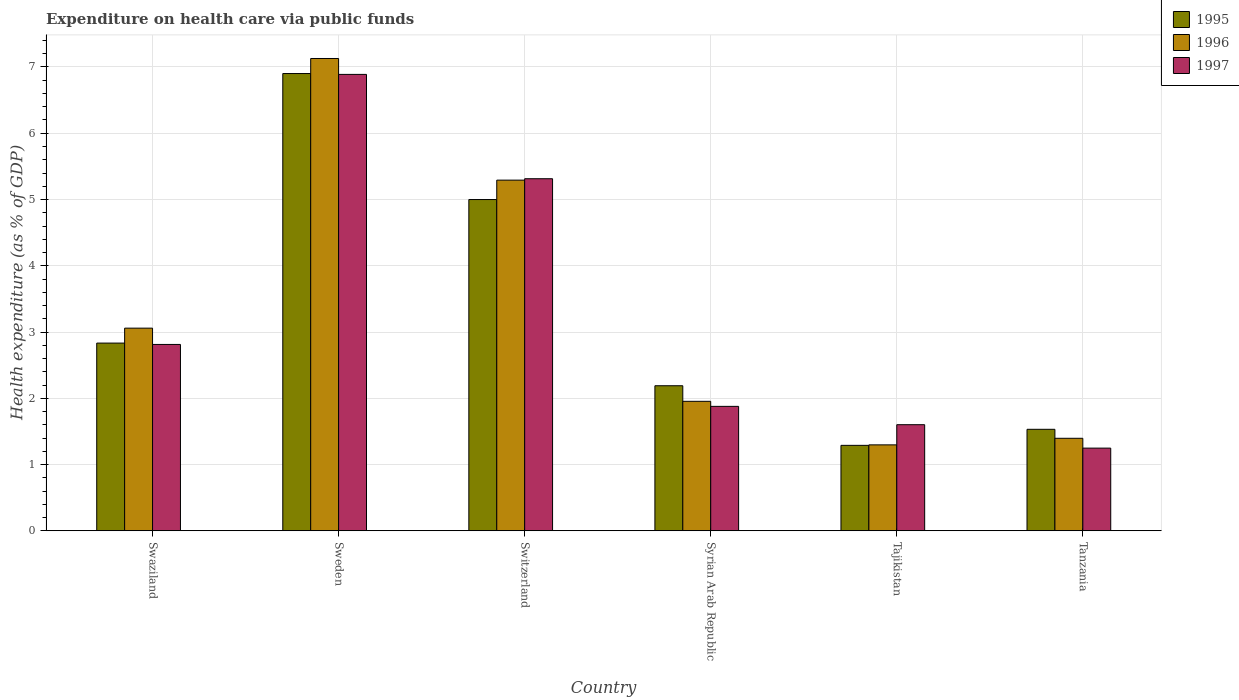How many different coloured bars are there?
Provide a succinct answer. 3. How many groups of bars are there?
Ensure brevity in your answer.  6. Are the number of bars per tick equal to the number of legend labels?
Keep it short and to the point. Yes. How many bars are there on the 2nd tick from the left?
Offer a very short reply. 3. How many bars are there on the 4th tick from the right?
Provide a short and direct response. 3. What is the label of the 6th group of bars from the left?
Your response must be concise. Tanzania. In how many cases, is the number of bars for a given country not equal to the number of legend labels?
Make the answer very short. 0. What is the expenditure made on health care in 1997 in Sweden?
Make the answer very short. 6.89. Across all countries, what is the maximum expenditure made on health care in 1995?
Your answer should be compact. 6.9. Across all countries, what is the minimum expenditure made on health care in 1996?
Your response must be concise. 1.3. In which country was the expenditure made on health care in 1996 maximum?
Your response must be concise. Sweden. In which country was the expenditure made on health care in 1995 minimum?
Provide a short and direct response. Tajikistan. What is the total expenditure made on health care in 1997 in the graph?
Ensure brevity in your answer.  19.74. What is the difference between the expenditure made on health care in 1995 in Sweden and that in Tajikistan?
Offer a terse response. 5.61. What is the difference between the expenditure made on health care in 1996 in Switzerland and the expenditure made on health care in 1997 in Sweden?
Provide a succinct answer. -1.6. What is the average expenditure made on health care in 1996 per country?
Make the answer very short. 3.35. What is the difference between the expenditure made on health care of/in 1996 and expenditure made on health care of/in 1997 in Swaziland?
Provide a succinct answer. 0.25. What is the ratio of the expenditure made on health care in 1997 in Tajikistan to that in Tanzania?
Your answer should be very brief. 1.28. Is the expenditure made on health care in 1996 in Switzerland less than that in Tajikistan?
Give a very brief answer. No. Is the difference between the expenditure made on health care in 1996 in Tajikistan and Tanzania greater than the difference between the expenditure made on health care in 1997 in Tajikistan and Tanzania?
Your answer should be compact. No. What is the difference between the highest and the second highest expenditure made on health care in 1997?
Provide a succinct answer. -2.5. What is the difference between the highest and the lowest expenditure made on health care in 1996?
Offer a terse response. 5.83. In how many countries, is the expenditure made on health care in 1997 greater than the average expenditure made on health care in 1997 taken over all countries?
Provide a succinct answer. 2. What does the 3rd bar from the left in Tajikistan represents?
Offer a very short reply. 1997. How many bars are there?
Your answer should be very brief. 18. Are all the bars in the graph horizontal?
Give a very brief answer. No. Are the values on the major ticks of Y-axis written in scientific E-notation?
Make the answer very short. No. Does the graph contain any zero values?
Make the answer very short. No. Does the graph contain grids?
Provide a short and direct response. Yes. Where does the legend appear in the graph?
Ensure brevity in your answer.  Top right. How many legend labels are there?
Offer a terse response. 3. What is the title of the graph?
Make the answer very short. Expenditure on health care via public funds. Does "1966" appear as one of the legend labels in the graph?
Your answer should be very brief. No. What is the label or title of the X-axis?
Your response must be concise. Country. What is the label or title of the Y-axis?
Your answer should be very brief. Health expenditure (as % of GDP). What is the Health expenditure (as % of GDP) in 1995 in Swaziland?
Ensure brevity in your answer.  2.83. What is the Health expenditure (as % of GDP) in 1996 in Swaziland?
Keep it short and to the point. 3.06. What is the Health expenditure (as % of GDP) in 1997 in Swaziland?
Your response must be concise. 2.81. What is the Health expenditure (as % of GDP) in 1995 in Sweden?
Provide a succinct answer. 6.9. What is the Health expenditure (as % of GDP) of 1996 in Sweden?
Keep it short and to the point. 7.13. What is the Health expenditure (as % of GDP) of 1997 in Sweden?
Give a very brief answer. 6.89. What is the Health expenditure (as % of GDP) of 1995 in Switzerland?
Keep it short and to the point. 5. What is the Health expenditure (as % of GDP) in 1996 in Switzerland?
Provide a short and direct response. 5.29. What is the Health expenditure (as % of GDP) of 1997 in Switzerland?
Your response must be concise. 5.31. What is the Health expenditure (as % of GDP) of 1995 in Syrian Arab Republic?
Provide a short and direct response. 2.19. What is the Health expenditure (as % of GDP) in 1996 in Syrian Arab Republic?
Offer a very short reply. 1.95. What is the Health expenditure (as % of GDP) in 1997 in Syrian Arab Republic?
Provide a short and direct response. 1.88. What is the Health expenditure (as % of GDP) in 1995 in Tajikistan?
Your response must be concise. 1.29. What is the Health expenditure (as % of GDP) in 1996 in Tajikistan?
Your response must be concise. 1.3. What is the Health expenditure (as % of GDP) of 1997 in Tajikistan?
Give a very brief answer. 1.6. What is the Health expenditure (as % of GDP) of 1995 in Tanzania?
Offer a terse response. 1.53. What is the Health expenditure (as % of GDP) in 1996 in Tanzania?
Ensure brevity in your answer.  1.4. What is the Health expenditure (as % of GDP) in 1997 in Tanzania?
Keep it short and to the point. 1.25. Across all countries, what is the maximum Health expenditure (as % of GDP) in 1995?
Your response must be concise. 6.9. Across all countries, what is the maximum Health expenditure (as % of GDP) of 1996?
Offer a terse response. 7.13. Across all countries, what is the maximum Health expenditure (as % of GDP) in 1997?
Provide a short and direct response. 6.89. Across all countries, what is the minimum Health expenditure (as % of GDP) of 1995?
Provide a short and direct response. 1.29. Across all countries, what is the minimum Health expenditure (as % of GDP) in 1996?
Your response must be concise. 1.3. Across all countries, what is the minimum Health expenditure (as % of GDP) in 1997?
Offer a very short reply. 1.25. What is the total Health expenditure (as % of GDP) of 1995 in the graph?
Make the answer very short. 19.74. What is the total Health expenditure (as % of GDP) of 1996 in the graph?
Ensure brevity in your answer.  20.13. What is the total Health expenditure (as % of GDP) of 1997 in the graph?
Offer a terse response. 19.74. What is the difference between the Health expenditure (as % of GDP) in 1995 in Swaziland and that in Sweden?
Offer a terse response. -4.07. What is the difference between the Health expenditure (as % of GDP) in 1996 in Swaziland and that in Sweden?
Offer a very short reply. -4.07. What is the difference between the Health expenditure (as % of GDP) in 1997 in Swaziland and that in Sweden?
Your answer should be compact. -4.08. What is the difference between the Health expenditure (as % of GDP) of 1995 in Swaziland and that in Switzerland?
Offer a terse response. -2.17. What is the difference between the Health expenditure (as % of GDP) in 1996 in Swaziland and that in Switzerland?
Your answer should be very brief. -2.23. What is the difference between the Health expenditure (as % of GDP) in 1997 in Swaziland and that in Switzerland?
Provide a succinct answer. -2.5. What is the difference between the Health expenditure (as % of GDP) of 1995 in Swaziland and that in Syrian Arab Republic?
Provide a succinct answer. 0.64. What is the difference between the Health expenditure (as % of GDP) of 1996 in Swaziland and that in Syrian Arab Republic?
Your response must be concise. 1.1. What is the difference between the Health expenditure (as % of GDP) of 1997 in Swaziland and that in Syrian Arab Republic?
Give a very brief answer. 0.93. What is the difference between the Health expenditure (as % of GDP) of 1995 in Swaziland and that in Tajikistan?
Provide a succinct answer. 1.54. What is the difference between the Health expenditure (as % of GDP) of 1996 in Swaziland and that in Tajikistan?
Your answer should be compact. 1.76. What is the difference between the Health expenditure (as % of GDP) of 1997 in Swaziland and that in Tajikistan?
Keep it short and to the point. 1.21. What is the difference between the Health expenditure (as % of GDP) of 1995 in Swaziland and that in Tanzania?
Your answer should be compact. 1.3. What is the difference between the Health expenditure (as % of GDP) of 1996 in Swaziland and that in Tanzania?
Your answer should be compact. 1.66. What is the difference between the Health expenditure (as % of GDP) of 1997 in Swaziland and that in Tanzania?
Offer a terse response. 1.56. What is the difference between the Health expenditure (as % of GDP) in 1995 in Sweden and that in Switzerland?
Your answer should be very brief. 1.9. What is the difference between the Health expenditure (as % of GDP) in 1996 in Sweden and that in Switzerland?
Ensure brevity in your answer.  1.84. What is the difference between the Health expenditure (as % of GDP) in 1997 in Sweden and that in Switzerland?
Offer a very short reply. 1.57. What is the difference between the Health expenditure (as % of GDP) in 1995 in Sweden and that in Syrian Arab Republic?
Your answer should be compact. 4.71. What is the difference between the Health expenditure (as % of GDP) of 1996 in Sweden and that in Syrian Arab Republic?
Give a very brief answer. 5.17. What is the difference between the Health expenditure (as % of GDP) in 1997 in Sweden and that in Syrian Arab Republic?
Keep it short and to the point. 5.01. What is the difference between the Health expenditure (as % of GDP) in 1995 in Sweden and that in Tajikistan?
Provide a short and direct response. 5.61. What is the difference between the Health expenditure (as % of GDP) in 1996 in Sweden and that in Tajikistan?
Your answer should be compact. 5.83. What is the difference between the Health expenditure (as % of GDP) in 1997 in Sweden and that in Tajikistan?
Keep it short and to the point. 5.29. What is the difference between the Health expenditure (as % of GDP) in 1995 in Sweden and that in Tanzania?
Provide a short and direct response. 5.37. What is the difference between the Health expenditure (as % of GDP) in 1996 in Sweden and that in Tanzania?
Offer a very short reply. 5.73. What is the difference between the Health expenditure (as % of GDP) of 1997 in Sweden and that in Tanzania?
Your response must be concise. 5.64. What is the difference between the Health expenditure (as % of GDP) of 1995 in Switzerland and that in Syrian Arab Republic?
Your response must be concise. 2.81. What is the difference between the Health expenditure (as % of GDP) of 1996 in Switzerland and that in Syrian Arab Republic?
Provide a short and direct response. 3.34. What is the difference between the Health expenditure (as % of GDP) in 1997 in Switzerland and that in Syrian Arab Republic?
Offer a very short reply. 3.44. What is the difference between the Health expenditure (as % of GDP) of 1995 in Switzerland and that in Tajikistan?
Your answer should be very brief. 3.71. What is the difference between the Health expenditure (as % of GDP) in 1996 in Switzerland and that in Tajikistan?
Keep it short and to the point. 4. What is the difference between the Health expenditure (as % of GDP) in 1997 in Switzerland and that in Tajikistan?
Provide a succinct answer. 3.71. What is the difference between the Health expenditure (as % of GDP) of 1995 in Switzerland and that in Tanzania?
Your response must be concise. 3.47. What is the difference between the Health expenditure (as % of GDP) in 1996 in Switzerland and that in Tanzania?
Ensure brevity in your answer.  3.9. What is the difference between the Health expenditure (as % of GDP) in 1997 in Switzerland and that in Tanzania?
Provide a short and direct response. 4.07. What is the difference between the Health expenditure (as % of GDP) in 1995 in Syrian Arab Republic and that in Tajikistan?
Your answer should be very brief. 0.9. What is the difference between the Health expenditure (as % of GDP) of 1996 in Syrian Arab Republic and that in Tajikistan?
Give a very brief answer. 0.66. What is the difference between the Health expenditure (as % of GDP) in 1997 in Syrian Arab Republic and that in Tajikistan?
Offer a very short reply. 0.28. What is the difference between the Health expenditure (as % of GDP) of 1995 in Syrian Arab Republic and that in Tanzania?
Your response must be concise. 0.66. What is the difference between the Health expenditure (as % of GDP) in 1996 in Syrian Arab Republic and that in Tanzania?
Provide a short and direct response. 0.56. What is the difference between the Health expenditure (as % of GDP) in 1997 in Syrian Arab Republic and that in Tanzania?
Provide a succinct answer. 0.63. What is the difference between the Health expenditure (as % of GDP) in 1995 in Tajikistan and that in Tanzania?
Keep it short and to the point. -0.24. What is the difference between the Health expenditure (as % of GDP) in 1996 in Tajikistan and that in Tanzania?
Your answer should be compact. -0.1. What is the difference between the Health expenditure (as % of GDP) in 1997 in Tajikistan and that in Tanzania?
Your answer should be very brief. 0.35. What is the difference between the Health expenditure (as % of GDP) of 1995 in Swaziland and the Health expenditure (as % of GDP) of 1996 in Sweden?
Provide a succinct answer. -4.3. What is the difference between the Health expenditure (as % of GDP) in 1995 in Swaziland and the Health expenditure (as % of GDP) in 1997 in Sweden?
Offer a very short reply. -4.06. What is the difference between the Health expenditure (as % of GDP) in 1996 in Swaziland and the Health expenditure (as % of GDP) in 1997 in Sweden?
Provide a short and direct response. -3.83. What is the difference between the Health expenditure (as % of GDP) in 1995 in Swaziland and the Health expenditure (as % of GDP) in 1996 in Switzerland?
Your answer should be compact. -2.46. What is the difference between the Health expenditure (as % of GDP) of 1995 in Swaziland and the Health expenditure (as % of GDP) of 1997 in Switzerland?
Ensure brevity in your answer.  -2.48. What is the difference between the Health expenditure (as % of GDP) of 1996 in Swaziland and the Health expenditure (as % of GDP) of 1997 in Switzerland?
Your response must be concise. -2.26. What is the difference between the Health expenditure (as % of GDP) of 1995 in Swaziland and the Health expenditure (as % of GDP) of 1996 in Syrian Arab Republic?
Your answer should be very brief. 0.88. What is the difference between the Health expenditure (as % of GDP) in 1995 in Swaziland and the Health expenditure (as % of GDP) in 1997 in Syrian Arab Republic?
Keep it short and to the point. 0.96. What is the difference between the Health expenditure (as % of GDP) in 1996 in Swaziland and the Health expenditure (as % of GDP) in 1997 in Syrian Arab Republic?
Your answer should be compact. 1.18. What is the difference between the Health expenditure (as % of GDP) in 1995 in Swaziland and the Health expenditure (as % of GDP) in 1996 in Tajikistan?
Provide a succinct answer. 1.54. What is the difference between the Health expenditure (as % of GDP) in 1995 in Swaziland and the Health expenditure (as % of GDP) in 1997 in Tajikistan?
Provide a short and direct response. 1.23. What is the difference between the Health expenditure (as % of GDP) in 1996 in Swaziland and the Health expenditure (as % of GDP) in 1997 in Tajikistan?
Make the answer very short. 1.46. What is the difference between the Health expenditure (as % of GDP) in 1995 in Swaziland and the Health expenditure (as % of GDP) in 1996 in Tanzania?
Offer a very short reply. 1.44. What is the difference between the Health expenditure (as % of GDP) of 1995 in Swaziland and the Health expenditure (as % of GDP) of 1997 in Tanzania?
Offer a very short reply. 1.59. What is the difference between the Health expenditure (as % of GDP) of 1996 in Swaziland and the Health expenditure (as % of GDP) of 1997 in Tanzania?
Your answer should be compact. 1.81. What is the difference between the Health expenditure (as % of GDP) in 1995 in Sweden and the Health expenditure (as % of GDP) in 1996 in Switzerland?
Offer a terse response. 1.61. What is the difference between the Health expenditure (as % of GDP) of 1995 in Sweden and the Health expenditure (as % of GDP) of 1997 in Switzerland?
Your response must be concise. 1.59. What is the difference between the Health expenditure (as % of GDP) in 1996 in Sweden and the Health expenditure (as % of GDP) in 1997 in Switzerland?
Offer a terse response. 1.81. What is the difference between the Health expenditure (as % of GDP) of 1995 in Sweden and the Health expenditure (as % of GDP) of 1996 in Syrian Arab Republic?
Ensure brevity in your answer.  4.95. What is the difference between the Health expenditure (as % of GDP) of 1995 in Sweden and the Health expenditure (as % of GDP) of 1997 in Syrian Arab Republic?
Make the answer very short. 5.02. What is the difference between the Health expenditure (as % of GDP) in 1996 in Sweden and the Health expenditure (as % of GDP) in 1997 in Syrian Arab Republic?
Ensure brevity in your answer.  5.25. What is the difference between the Health expenditure (as % of GDP) in 1995 in Sweden and the Health expenditure (as % of GDP) in 1996 in Tajikistan?
Give a very brief answer. 5.6. What is the difference between the Health expenditure (as % of GDP) of 1996 in Sweden and the Health expenditure (as % of GDP) of 1997 in Tajikistan?
Provide a succinct answer. 5.53. What is the difference between the Health expenditure (as % of GDP) in 1995 in Sweden and the Health expenditure (as % of GDP) in 1996 in Tanzania?
Offer a very short reply. 5.51. What is the difference between the Health expenditure (as % of GDP) of 1995 in Sweden and the Health expenditure (as % of GDP) of 1997 in Tanzania?
Your answer should be compact. 5.65. What is the difference between the Health expenditure (as % of GDP) in 1996 in Sweden and the Health expenditure (as % of GDP) in 1997 in Tanzania?
Provide a succinct answer. 5.88. What is the difference between the Health expenditure (as % of GDP) of 1995 in Switzerland and the Health expenditure (as % of GDP) of 1996 in Syrian Arab Republic?
Your answer should be very brief. 3.05. What is the difference between the Health expenditure (as % of GDP) in 1995 in Switzerland and the Health expenditure (as % of GDP) in 1997 in Syrian Arab Republic?
Your answer should be compact. 3.12. What is the difference between the Health expenditure (as % of GDP) in 1996 in Switzerland and the Health expenditure (as % of GDP) in 1997 in Syrian Arab Republic?
Your answer should be very brief. 3.41. What is the difference between the Health expenditure (as % of GDP) in 1995 in Switzerland and the Health expenditure (as % of GDP) in 1996 in Tajikistan?
Ensure brevity in your answer.  3.7. What is the difference between the Health expenditure (as % of GDP) in 1995 in Switzerland and the Health expenditure (as % of GDP) in 1997 in Tajikistan?
Offer a very short reply. 3.4. What is the difference between the Health expenditure (as % of GDP) of 1996 in Switzerland and the Health expenditure (as % of GDP) of 1997 in Tajikistan?
Your response must be concise. 3.69. What is the difference between the Health expenditure (as % of GDP) in 1995 in Switzerland and the Health expenditure (as % of GDP) in 1996 in Tanzania?
Ensure brevity in your answer.  3.6. What is the difference between the Health expenditure (as % of GDP) of 1995 in Switzerland and the Health expenditure (as % of GDP) of 1997 in Tanzania?
Provide a succinct answer. 3.75. What is the difference between the Health expenditure (as % of GDP) in 1996 in Switzerland and the Health expenditure (as % of GDP) in 1997 in Tanzania?
Provide a short and direct response. 4.04. What is the difference between the Health expenditure (as % of GDP) in 1995 in Syrian Arab Republic and the Health expenditure (as % of GDP) in 1996 in Tajikistan?
Provide a short and direct response. 0.89. What is the difference between the Health expenditure (as % of GDP) of 1995 in Syrian Arab Republic and the Health expenditure (as % of GDP) of 1997 in Tajikistan?
Your answer should be compact. 0.59. What is the difference between the Health expenditure (as % of GDP) in 1996 in Syrian Arab Republic and the Health expenditure (as % of GDP) in 1997 in Tajikistan?
Provide a short and direct response. 0.35. What is the difference between the Health expenditure (as % of GDP) in 1995 in Syrian Arab Republic and the Health expenditure (as % of GDP) in 1996 in Tanzania?
Your answer should be very brief. 0.79. What is the difference between the Health expenditure (as % of GDP) in 1995 in Syrian Arab Republic and the Health expenditure (as % of GDP) in 1997 in Tanzania?
Keep it short and to the point. 0.94. What is the difference between the Health expenditure (as % of GDP) of 1996 in Syrian Arab Republic and the Health expenditure (as % of GDP) of 1997 in Tanzania?
Your answer should be compact. 0.71. What is the difference between the Health expenditure (as % of GDP) in 1995 in Tajikistan and the Health expenditure (as % of GDP) in 1996 in Tanzania?
Keep it short and to the point. -0.11. What is the difference between the Health expenditure (as % of GDP) of 1995 in Tajikistan and the Health expenditure (as % of GDP) of 1997 in Tanzania?
Offer a terse response. 0.04. What is the difference between the Health expenditure (as % of GDP) in 1996 in Tajikistan and the Health expenditure (as % of GDP) in 1997 in Tanzania?
Give a very brief answer. 0.05. What is the average Health expenditure (as % of GDP) of 1995 per country?
Provide a short and direct response. 3.29. What is the average Health expenditure (as % of GDP) of 1996 per country?
Offer a very short reply. 3.35. What is the average Health expenditure (as % of GDP) in 1997 per country?
Provide a short and direct response. 3.29. What is the difference between the Health expenditure (as % of GDP) in 1995 and Health expenditure (as % of GDP) in 1996 in Swaziland?
Give a very brief answer. -0.23. What is the difference between the Health expenditure (as % of GDP) of 1995 and Health expenditure (as % of GDP) of 1997 in Swaziland?
Give a very brief answer. 0.02. What is the difference between the Health expenditure (as % of GDP) in 1996 and Health expenditure (as % of GDP) in 1997 in Swaziland?
Your answer should be very brief. 0.25. What is the difference between the Health expenditure (as % of GDP) of 1995 and Health expenditure (as % of GDP) of 1996 in Sweden?
Make the answer very short. -0.23. What is the difference between the Health expenditure (as % of GDP) of 1995 and Health expenditure (as % of GDP) of 1997 in Sweden?
Provide a short and direct response. 0.01. What is the difference between the Health expenditure (as % of GDP) of 1996 and Health expenditure (as % of GDP) of 1997 in Sweden?
Ensure brevity in your answer.  0.24. What is the difference between the Health expenditure (as % of GDP) of 1995 and Health expenditure (as % of GDP) of 1996 in Switzerland?
Provide a short and direct response. -0.29. What is the difference between the Health expenditure (as % of GDP) in 1995 and Health expenditure (as % of GDP) in 1997 in Switzerland?
Your answer should be compact. -0.31. What is the difference between the Health expenditure (as % of GDP) in 1996 and Health expenditure (as % of GDP) in 1997 in Switzerland?
Your answer should be very brief. -0.02. What is the difference between the Health expenditure (as % of GDP) in 1995 and Health expenditure (as % of GDP) in 1996 in Syrian Arab Republic?
Your answer should be very brief. 0.24. What is the difference between the Health expenditure (as % of GDP) of 1995 and Health expenditure (as % of GDP) of 1997 in Syrian Arab Republic?
Ensure brevity in your answer.  0.31. What is the difference between the Health expenditure (as % of GDP) of 1996 and Health expenditure (as % of GDP) of 1997 in Syrian Arab Republic?
Provide a short and direct response. 0.08. What is the difference between the Health expenditure (as % of GDP) of 1995 and Health expenditure (as % of GDP) of 1996 in Tajikistan?
Make the answer very short. -0.01. What is the difference between the Health expenditure (as % of GDP) of 1995 and Health expenditure (as % of GDP) of 1997 in Tajikistan?
Your response must be concise. -0.31. What is the difference between the Health expenditure (as % of GDP) in 1996 and Health expenditure (as % of GDP) in 1997 in Tajikistan?
Your answer should be very brief. -0.3. What is the difference between the Health expenditure (as % of GDP) in 1995 and Health expenditure (as % of GDP) in 1996 in Tanzania?
Make the answer very short. 0.14. What is the difference between the Health expenditure (as % of GDP) of 1995 and Health expenditure (as % of GDP) of 1997 in Tanzania?
Provide a short and direct response. 0.28. What is the difference between the Health expenditure (as % of GDP) in 1996 and Health expenditure (as % of GDP) in 1997 in Tanzania?
Offer a very short reply. 0.15. What is the ratio of the Health expenditure (as % of GDP) of 1995 in Swaziland to that in Sweden?
Your response must be concise. 0.41. What is the ratio of the Health expenditure (as % of GDP) in 1996 in Swaziland to that in Sweden?
Ensure brevity in your answer.  0.43. What is the ratio of the Health expenditure (as % of GDP) in 1997 in Swaziland to that in Sweden?
Keep it short and to the point. 0.41. What is the ratio of the Health expenditure (as % of GDP) in 1995 in Swaziland to that in Switzerland?
Make the answer very short. 0.57. What is the ratio of the Health expenditure (as % of GDP) of 1996 in Swaziland to that in Switzerland?
Offer a very short reply. 0.58. What is the ratio of the Health expenditure (as % of GDP) of 1997 in Swaziland to that in Switzerland?
Give a very brief answer. 0.53. What is the ratio of the Health expenditure (as % of GDP) in 1995 in Swaziland to that in Syrian Arab Republic?
Give a very brief answer. 1.29. What is the ratio of the Health expenditure (as % of GDP) of 1996 in Swaziland to that in Syrian Arab Republic?
Provide a short and direct response. 1.57. What is the ratio of the Health expenditure (as % of GDP) of 1997 in Swaziland to that in Syrian Arab Republic?
Your response must be concise. 1.5. What is the ratio of the Health expenditure (as % of GDP) in 1995 in Swaziland to that in Tajikistan?
Give a very brief answer. 2.2. What is the ratio of the Health expenditure (as % of GDP) of 1996 in Swaziland to that in Tajikistan?
Ensure brevity in your answer.  2.36. What is the ratio of the Health expenditure (as % of GDP) of 1997 in Swaziland to that in Tajikistan?
Provide a short and direct response. 1.76. What is the ratio of the Health expenditure (as % of GDP) in 1995 in Swaziland to that in Tanzania?
Make the answer very short. 1.85. What is the ratio of the Health expenditure (as % of GDP) of 1996 in Swaziland to that in Tanzania?
Your response must be concise. 2.19. What is the ratio of the Health expenditure (as % of GDP) of 1997 in Swaziland to that in Tanzania?
Keep it short and to the point. 2.25. What is the ratio of the Health expenditure (as % of GDP) of 1995 in Sweden to that in Switzerland?
Keep it short and to the point. 1.38. What is the ratio of the Health expenditure (as % of GDP) in 1996 in Sweden to that in Switzerland?
Give a very brief answer. 1.35. What is the ratio of the Health expenditure (as % of GDP) in 1997 in Sweden to that in Switzerland?
Offer a terse response. 1.3. What is the ratio of the Health expenditure (as % of GDP) in 1995 in Sweden to that in Syrian Arab Republic?
Provide a short and direct response. 3.15. What is the ratio of the Health expenditure (as % of GDP) of 1996 in Sweden to that in Syrian Arab Republic?
Your answer should be very brief. 3.65. What is the ratio of the Health expenditure (as % of GDP) in 1997 in Sweden to that in Syrian Arab Republic?
Make the answer very short. 3.67. What is the ratio of the Health expenditure (as % of GDP) of 1995 in Sweden to that in Tajikistan?
Give a very brief answer. 5.35. What is the ratio of the Health expenditure (as % of GDP) of 1996 in Sweden to that in Tajikistan?
Your answer should be very brief. 5.5. What is the ratio of the Health expenditure (as % of GDP) of 1997 in Sweden to that in Tajikistan?
Your answer should be compact. 4.3. What is the ratio of the Health expenditure (as % of GDP) of 1995 in Sweden to that in Tanzania?
Ensure brevity in your answer.  4.51. What is the ratio of the Health expenditure (as % of GDP) of 1996 in Sweden to that in Tanzania?
Keep it short and to the point. 5.11. What is the ratio of the Health expenditure (as % of GDP) in 1997 in Sweden to that in Tanzania?
Offer a very short reply. 5.52. What is the ratio of the Health expenditure (as % of GDP) in 1995 in Switzerland to that in Syrian Arab Republic?
Offer a very short reply. 2.28. What is the ratio of the Health expenditure (as % of GDP) in 1996 in Switzerland to that in Syrian Arab Republic?
Offer a very short reply. 2.71. What is the ratio of the Health expenditure (as % of GDP) in 1997 in Switzerland to that in Syrian Arab Republic?
Offer a terse response. 2.83. What is the ratio of the Health expenditure (as % of GDP) of 1995 in Switzerland to that in Tajikistan?
Provide a succinct answer. 3.88. What is the ratio of the Health expenditure (as % of GDP) of 1996 in Switzerland to that in Tajikistan?
Ensure brevity in your answer.  4.08. What is the ratio of the Health expenditure (as % of GDP) of 1997 in Switzerland to that in Tajikistan?
Your answer should be compact. 3.32. What is the ratio of the Health expenditure (as % of GDP) in 1995 in Switzerland to that in Tanzania?
Offer a very short reply. 3.26. What is the ratio of the Health expenditure (as % of GDP) in 1996 in Switzerland to that in Tanzania?
Your answer should be compact. 3.79. What is the ratio of the Health expenditure (as % of GDP) of 1997 in Switzerland to that in Tanzania?
Provide a short and direct response. 4.26. What is the ratio of the Health expenditure (as % of GDP) in 1995 in Syrian Arab Republic to that in Tajikistan?
Give a very brief answer. 1.7. What is the ratio of the Health expenditure (as % of GDP) of 1996 in Syrian Arab Republic to that in Tajikistan?
Your response must be concise. 1.51. What is the ratio of the Health expenditure (as % of GDP) of 1997 in Syrian Arab Republic to that in Tajikistan?
Your answer should be very brief. 1.17. What is the ratio of the Health expenditure (as % of GDP) in 1995 in Syrian Arab Republic to that in Tanzania?
Make the answer very short. 1.43. What is the ratio of the Health expenditure (as % of GDP) in 1996 in Syrian Arab Republic to that in Tanzania?
Provide a succinct answer. 1.4. What is the ratio of the Health expenditure (as % of GDP) of 1997 in Syrian Arab Republic to that in Tanzania?
Keep it short and to the point. 1.5. What is the ratio of the Health expenditure (as % of GDP) in 1995 in Tajikistan to that in Tanzania?
Make the answer very short. 0.84. What is the ratio of the Health expenditure (as % of GDP) of 1996 in Tajikistan to that in Tanzania?
Your answer should be very brief. 0.93. What is the ratio of the Health expenditure (as % of GDP) in 1997 in Tajikistan to that in Tanzania?
Your answer should be compact. 1.28. What is the difference between the highest and the second highest Health expenditure (as % of GDP) in 1995?
Offer a terse response. 1.9. What is the difference between the highest and the second highest Health expenditure (as % of GDP) of 1996?
Keep it short and to the point. 1.84. What is the difference between the highest and the second highest Health expenditure (as % of GDP) of 1997?
Ensure brevity in your answer.  1.57. What is the difference between the highest and the lowest Health expenditure (as % of GDP) in 1995?
Offer a very short reply. 5.61. What is the difference between the highest and the lowest Health expenditure (as % of GDP) in 1996?
Keep it short and to the point. 5.83. What is the difference between the highest and the lowest Health expenditure (as % of GDP) of 1997?
Make the answer very short. 5.64. 